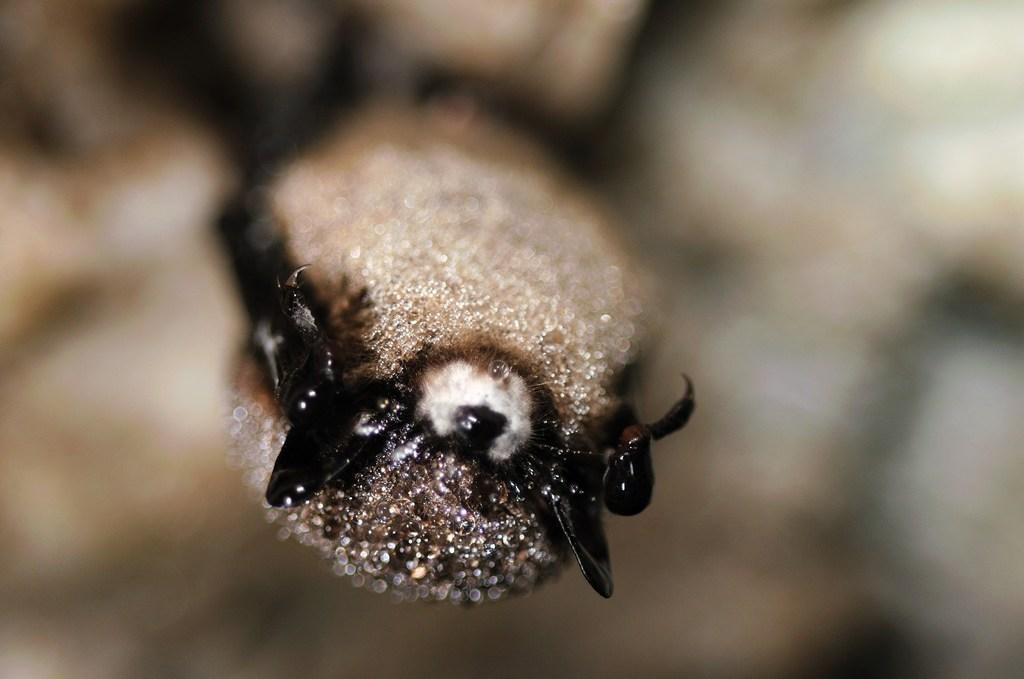Describe this image in one or two sentences. In this picture we can see an insect. Behind the insect, there is the blurred background. 